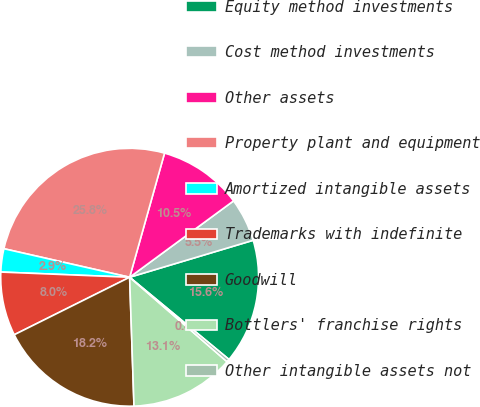<chart> <loc_0><loc_0><loc_500><loc_500><pie_chart><fcel>Equity method investments<fcel>Cost method investments<fcel>Other assets<fcel>Property plant and equipment<fcel>Amortized intangible assets<fcel>Trademarks with indefinite<fcel>Goodwill<fcel>Bottlers' franchise rights<fcel>Other intangible assets not<nl><fcel>15.63%<fcel>5.46%<fcel>10.55%<fcel>25.81%<fcel>2.91%<fcel>8.0%<fcel>18.18%<fcel>13.09%<fcel>0.37%<nl></chart> 